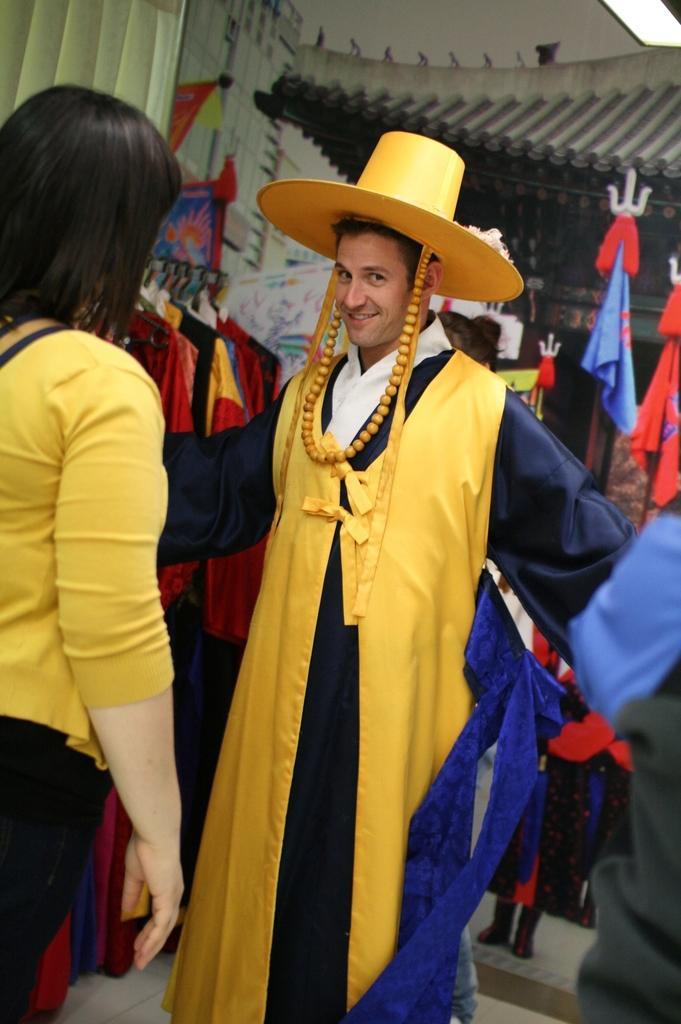Can you describe this image briefly? In this picture we can see a man wearing a costume with a hat and looking at someone. There is a woman standing in front of him. 